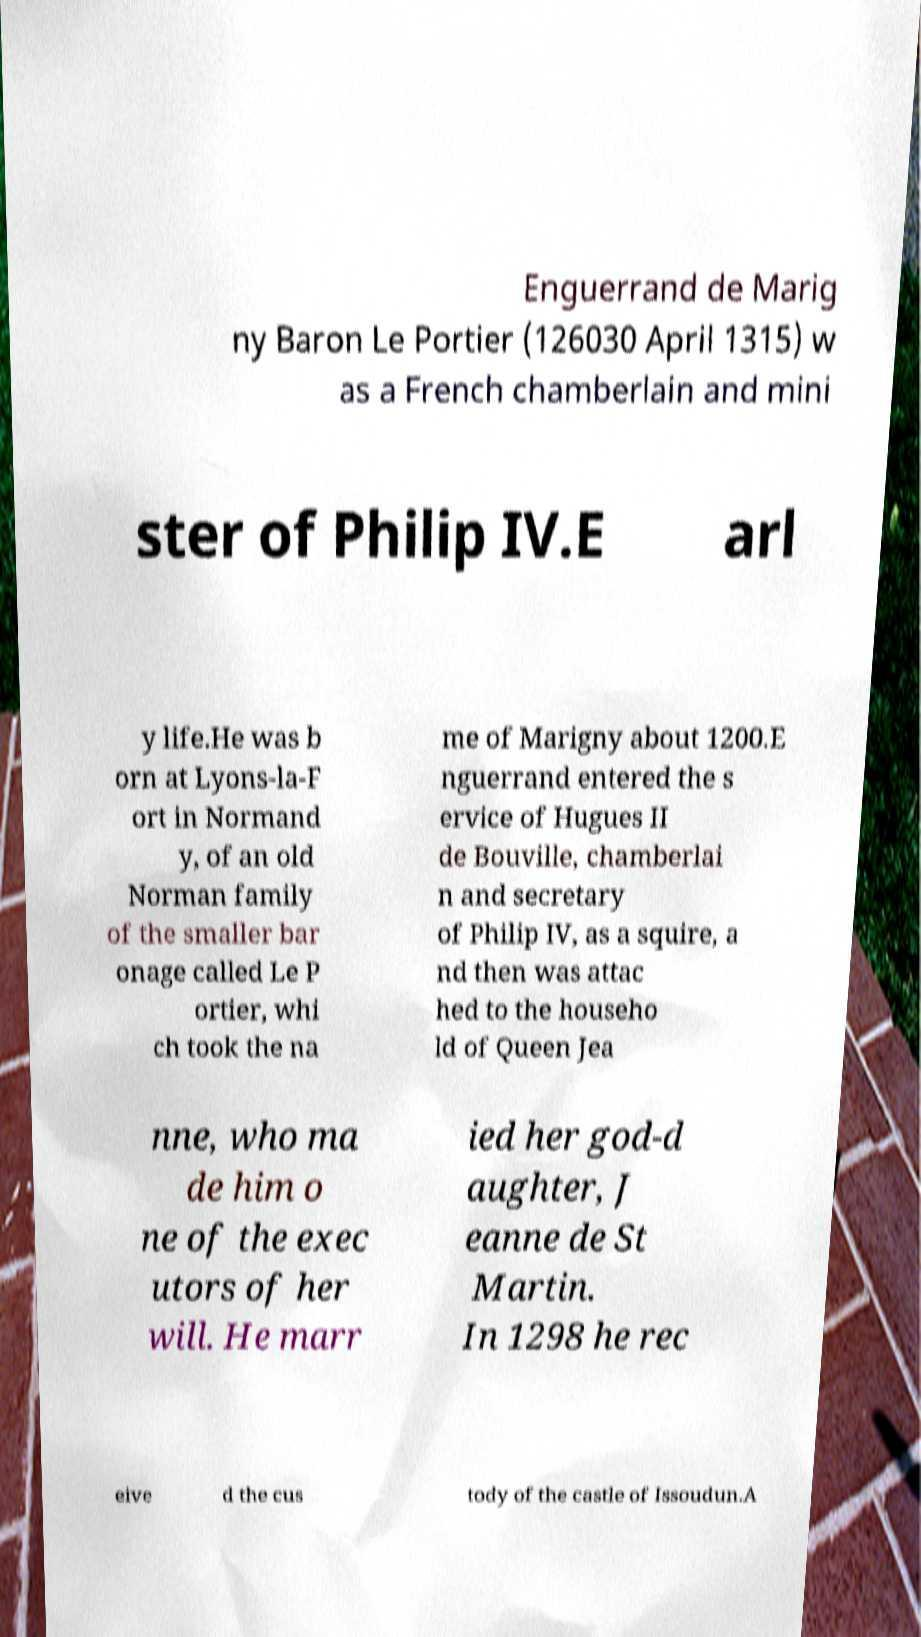Could you assist in decoding the text presented in this image and type it out clearly? Enguerrand de Marig ny Baron Le Portier (126030 April 1315) w as a French chamberlain and mini ster of Philip IV.E arl y life.He was b orn at Lyons-la-F ort in Normand y, of an old Norman family of the smaller bar onage called Le P ortier, whi ch took the na me of Marigny about 1200.E nguerrand entered the s ervice of Hugues II de Bouville, chamberlai n and secretary of Philip IV, as a squire, a nd then was attac hed to the househo ld of Queen Jea nne, who ma de him o ne of the exec utors of her will. He marr ied her god-d aughter, J eanne de St Martin. In 1298 he rec eive d the cus tody of the castle of Issoudun.A 